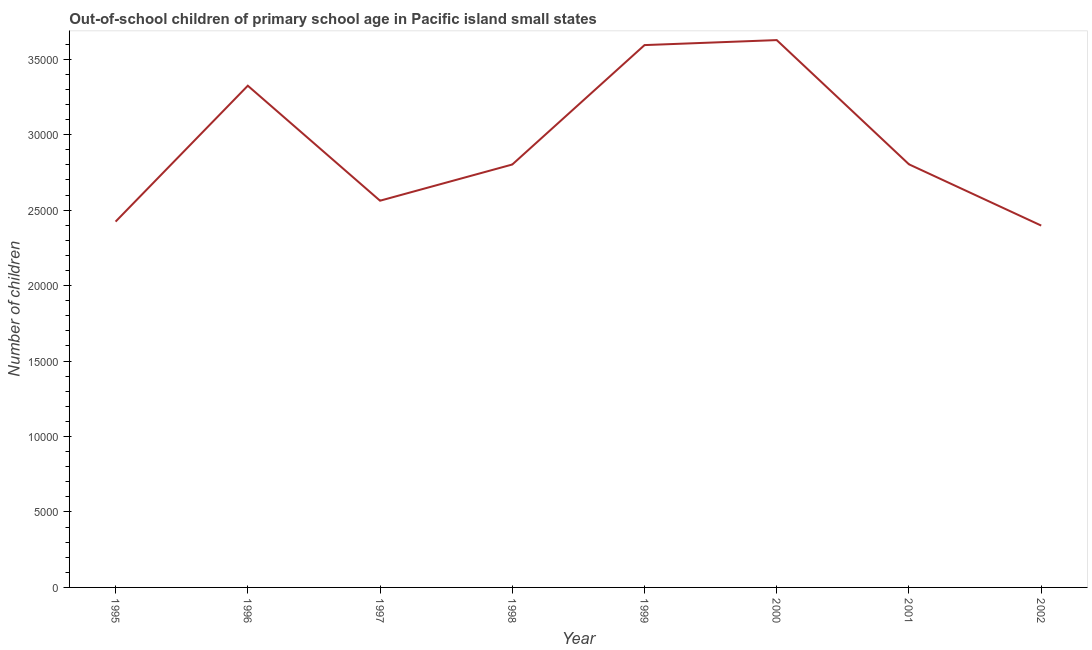What is the number of out-of-school children in 1995?
Your response must be concise. 2.42e+04. Across all years, what is the maximum number of out-of-school children?
Provide a short and direct response. 3.63e+04. Across all years, what is the minimum number of out-of-school children?
Keep it short and to the point. 2.40e+04. In which year was the number of out-of-school children maximum?
Keep it short and to the point. 2000. What is the sum of the number of out-of-school children?
Keep it short and to the point. 2.35e+05. What is the difference between the number of out-of-school children in 2000 and 2001?
Offer a terse response. 8231. What is the average number of out-of-school children per year?
Make the answer very short. 2.94e+04. What is the median number of out-of-school children?
Your response must be concise. 2.80e+04. What is the ratio of the number of out-of-school children in 1996 to that in 2001?
Your response must be concise. 1.19. Is the difference between the number of out-of-school children in 1997 and 2001 greater than the difference between any two years?
Your answer should be very brief. No. What is the difference between the highest and the second highest number of out-of-school children?
Ensure brevity in your answer.  331. Is the sum of the number of out-of-school children in 1995 and 1997 greater than the maximum number of out-of-school children across all years?
Keep it short and to the point. Yes. What is the difference between the highest and the lowest number of out-of-school children?
Keep it short and to the point. 1.23e+04. Does the number of out-of-school children monotonically increase over the years?
Provide a succinct answer. No. How many lines are there?
Your answer should be very brief. 1. How many years are there in the graph?
Your response must be concise. 8. Does the graph contain any zero values?
Your answer should be compact. No. What is the title of the graph?
Your response must be concise. Out-of-school children of primary school age in Pacific island small states. What is the label or title of the X-axis?
Offer a very short reply. Year. What is the label or title of the Y-axis?
Make the answer very short. Number of children. What is the Number of children of 1995?
Provide a succinct answer. 2.42e+04. What is the Number of children in 1996?
Give a very brief answer. 3.32e+04. What is the Number of children in 1997?
Your answer should be compact. 2.56e+04. What is the Number of children in 1998?
Ensure brevity in your answer.  2.80e+04. What is the Number of children in 1999?
Your answer should be very brief. 3.59e+04. What is the Number of children in 2000?
Provide a short and direct response. 3.63e+04. What is the Number of children of 2001?
Provide a short and direct response. 2.80e+04. What is the Number of children of 2002?
Provide a short and direct response. 2.40e+04. What is the difference between the Number of children in 1995 and 1996?
Offer a terse response. -9005. What is the difference between the Number of children in 1995 and 1997?
Your answer should be compact. -1386. What is the difference between the Number of children in 1995 and 1998?
Provide a succinct answer. -3784. What is the difference between the Number of children in 1995 and 1999?
Keep it short and to the point. -1.17e+04. What is the difference between the Number of children in 1995 and 2000?
Your response must be concise. -1.20e+04. What is the difference between the Number of children in 1995 and 2001?
Give a very brief answer. -3796. What is the difference between the Number of children in 1995 and 2002?
Your answer should be compact. 262. What is the difference between the Number of children in 1996 and 1997?
Make the answer very short. 7619. What is the difference between the Number of children in 1996 and 1998?
Ensure brevity in your answer.  5221. What is the difference between the Number of children in 1996 and 1999?
Your answer should be compact. -2691. What is the difference between the Number of children in 1996 and 2000?
Your answer should be very brief. -3022. What is the difference between the Number of children in 1996 and 2001?
Give a very brief answer. 5209. What is the difference between the Number of children in 1996 and 2002?
Your answer should be compact. 9267. What is the difference between the Number of children in 1997 and 1998?
Keep it short and to the point. -2398. What is the difference between the Number of children in 1997 and 1999?
Provide a succinct answer. -1.03e+04. What is the difference between the Number of children in 1997 and 2000?
Offer a very short reply. -1.06e+04. What is the difference between the Number of children in 1997 and 2001?
Keep it short and to the point. -2410. What is the difference between the Number of children in 1997 and 2002?
Give a very brief answer. 1648. What is the difference between the Number of children in 1998 and 1999?
Your response must be concise. -7912. What is the difference between the Number of children in 1998 and 2000?
Ensure brevity in your answer.  -8243. What is the difference between the Number of children in 1998 and 2002?
Your answer should be compact. 4046. What is the difference between the Number of children in 1999 and 2000?
Ensure brevity in your answer.  -331. What is the difference between the Number of children in 1999 and 2001?
Offer a very short reply. 7900. What is the difference between the Number of children in 1999 and 2002?
Ensure brevity in your answer.  1.20e+04. What is the difference between the Number of children in 2000 and 2001?
Give a very brief answer. 8231. What is the difference between the Number of children in 2000 and 2002?
Your answer should be compact. 1.23e+04. What is the difference between the Number of children in 2001 and 2002?
Make the answer very short. 4058. What is the ratio of the Number of children in 1995 to that in 1996?
Provide a short and direct response. 0.73. What is the ratio of the Number of children in 1995 to that in 1997?
Give a very brief answer. 0.95. What is the ratio of the Number of children in 1995 to that in 1998?
Your answer should be compact. 0.86. What is the ratio of the Number of children in 1995 to that in 1999?
Give a very brief answer. 0.68. What is the ratio of the Number of children in 1995 to that in 2000?
Provide a short and direct response. 0.67. What is the ratio of the Number of children in 1995 to that in 2001?
Offer a terse response. 0.86. What is the ratio of the Number of children in 1996 to that in 1997?
Provide a succinct answer. 1.3. What is the ratio of the Number of children in 1996 to that in 1998?
Make the answer very short. 1.19. What is the ratio of the Number of children in 1996 to that in 1999?
Your response must be concise. 0.93. What is the ratio of the Number of children in 1996 to that in 2000?
Give a very brief answer. 0.92. What is the ratio of the Number of children in 1996 to that in 2001?
Offer a terse response. 1.19. What is the ratio of the Number of children in 1996 to that in 2002?
Your response must be concise. 1.39. What is the ratio of the Number of children in 1997 to that in 1998?
Provide a succinct answer. 0.91. What is the ratio of the Number of children in 1997 to that in 1999?
Your response must be concise. 0.71. What is the ratio of the Number of children in 1997 to that in 2000?
Offer a terse response. 0.71. What is the ratio of the Number of children in 1997 to that in 2001?
Give a very brief answer. 0.91. What is the ratio of the Number of children in 1997 to that in 2002?
Make the answer very short. 1.07. What is the ratio of the Number of children in 1998 to that in 1999?
Provide a short and direct response. 0.78. What is the ratio of the Number of children in 1998 to that in 2000?
Your answer should be very brief. 0.77. What is the ratio of the Number of children in 1998 to that in 2002?
Provide a short and direct response. 1.17. What is the ratio of the Number of children in 1999 to that in 2000?
Offer a terse response. 0.99. What is the ratio of the Number of children in 1999 to that in 2001?
Your answer should be compact. 1.28. What is the ratio of the Number of children in 1999 to that in 2002?
Your answer should be compact. 1.5. What is the ratio of the Number of children in 2000 to that in 2001?
Make the answer very short. 1.29. What is the ratio of the Number of children in 2000 to that in 2002?
Ensure brevity in your answer.  1.51. What is the ratio of the Number of children in 2001 to that in 2002?
Provide a short and direct response. 1.17. 